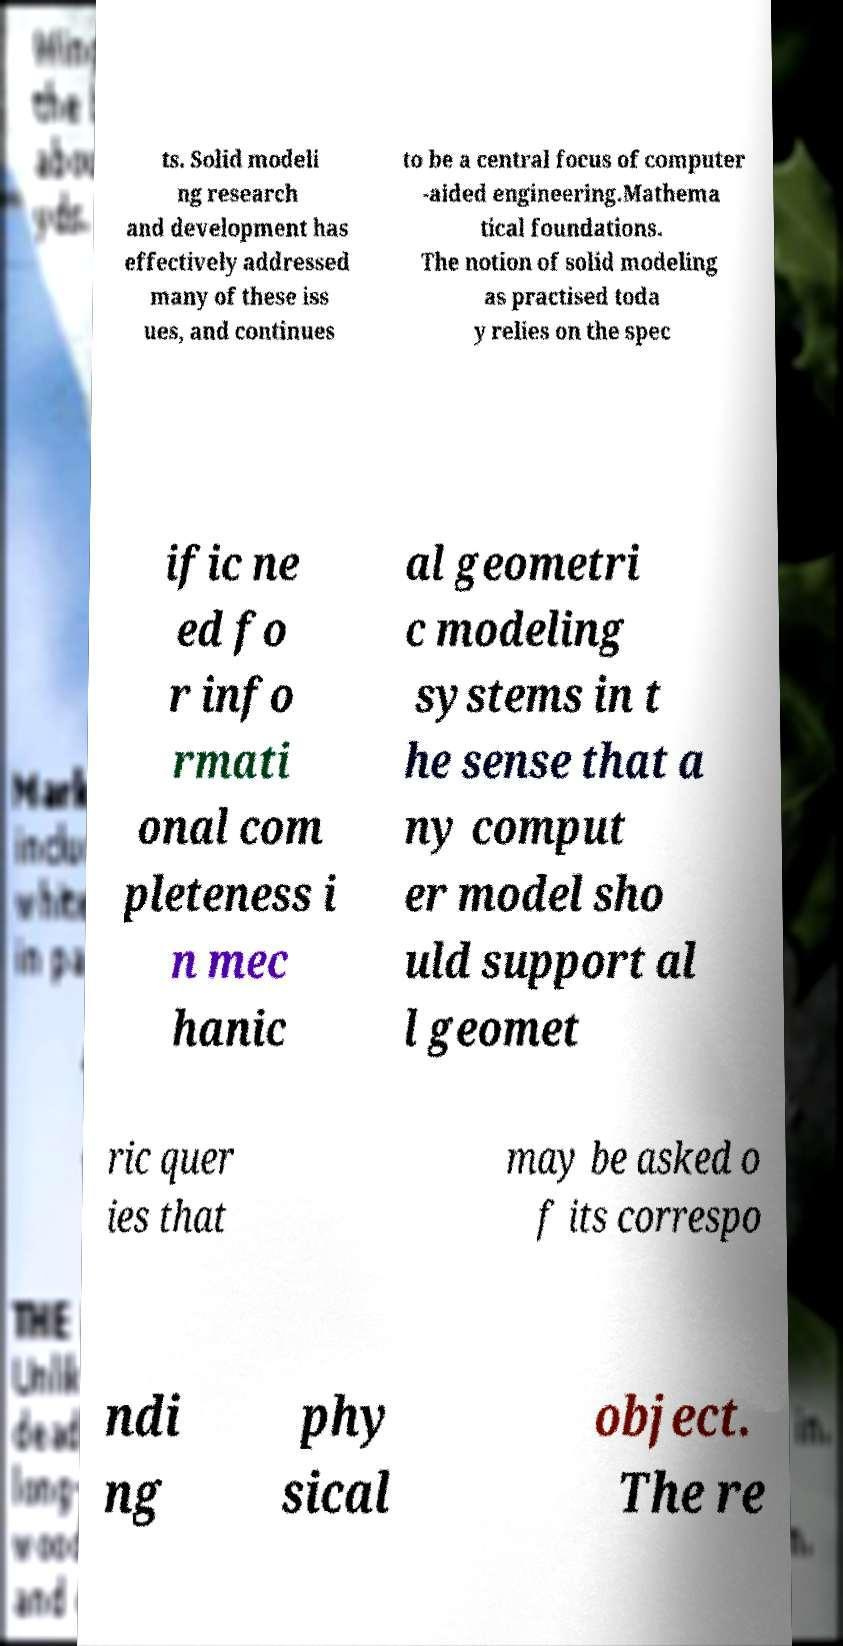I need the written content from this picture converted into text. Can you do that? ts. Solid modeli ng research and development has effectively addressed many of these iss ues, and continues to be a central focus of computer -aided engineering.Mathema tical foundations. The notion of solid modeling as practised toda y relies on the spec ific ne ed fo r info rmati onal com pleteness i n mec hanic al geometri c modeling systems in t he sense that a ny comput er model sho uld support al l geomet ric quer ies that may be asked o f its correspo ndi ng phy sical object. The re 